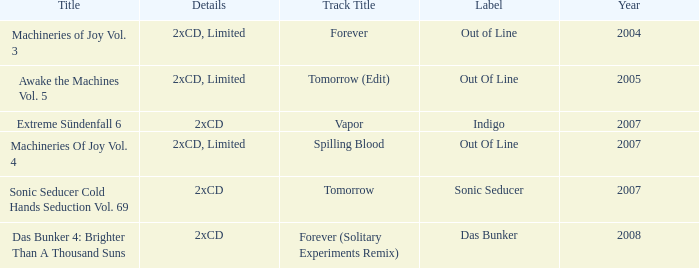Which label has a year older than 2004 and a 2xcd detail as well as the sonic seducer cold hands seduction vol. 69 title? Sonic Seducer. 